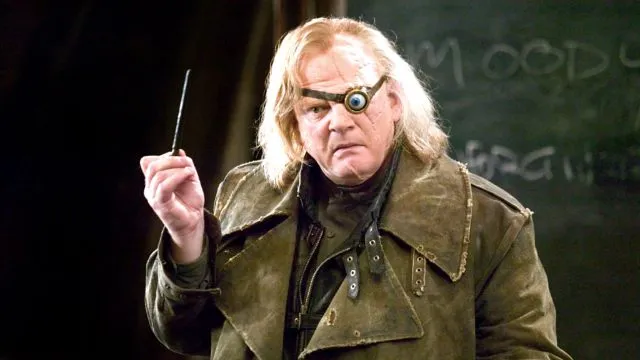Is there any notable text or background detail that adds to the scene? In the background, we see a blackboard with some partially legible text that appears to spell out 'MOODY.' This subtle detail reinforces the character's identity, adding a layer to the setting by placing us in a classroom or training environment where 'Mad-Eye' Moody might be instructing students or fellow Aurors. This detail, although minor, ties the scene to his role as a teacher and mentor in the Harry Potter series. 